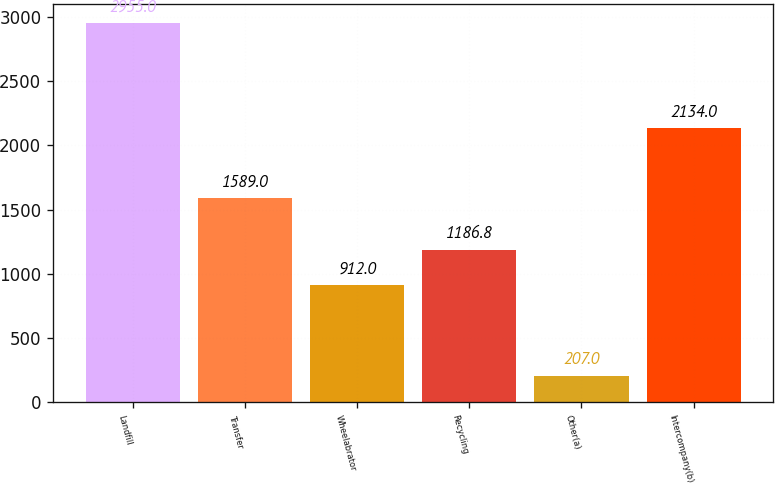Convert chart. <chart><loc_0><loc_0><loc_500><loc_500><bar_chart><fcel>Landfill<fcel>Transfer<fcel>Wheelabrator<fcel>Recycling<fcel>Other(a)<fcel>Intercompany(b)<nl><fcel>2955<fcel>1589<fcel>912<fcel>1186.8<fcel>207<fcel>2134<nl></chart> 